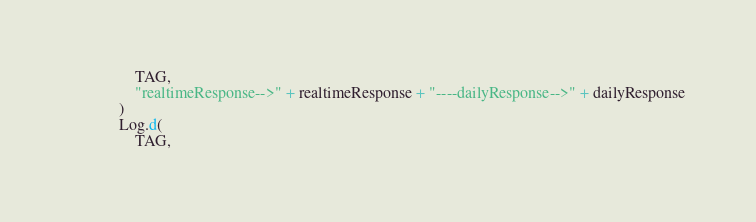<code> <loc_0><loc_0><loc_500><loc_500><_Kotlin_>                TAG,
                "realtimeResponse-->" + realtimeResponse + "----dailyResponse-->" + dailyResponse
            )
            Log.d(
                TAG,</code> 